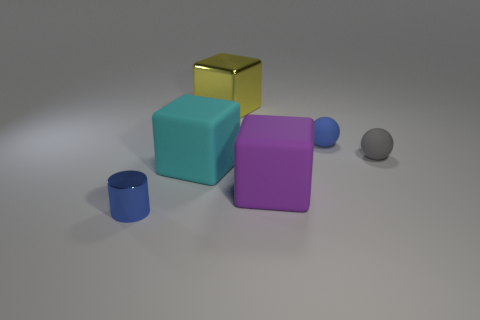Subtract all large yellow shiny blocks. How many blocks are left? 2 Add 3 big yellow objects. How many objects exist? 9 Subtract all yellow cubes. How many cubes are left? 2 Subtract all purple cylinders. Subtract all green cubes. How many cylinders are left? 1 Subtract all small spheres. Subtract all purple cubes. How many objects are left? 3 Add 6 blue rubber spheres. How many blue rubber spheres are left? 7 Add 6 rubber spheres. How many rubber spheres exist? 8 Subtract 1 gray spheres. How many objects are left? 5 Subtract all cylinders. How many objects are left? 5 